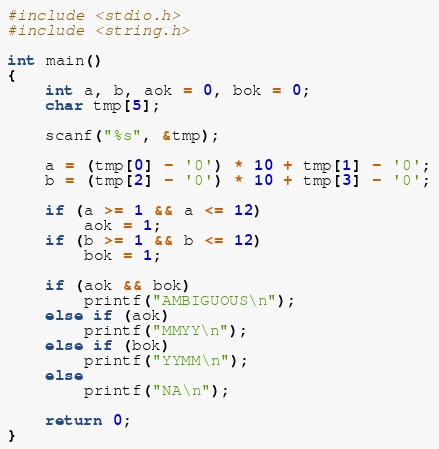Convert code to text. <code><loc_0><loc_0><loc_500><loc_500><_C_>#include <stdio.h>
#include <string.h>

int main()
{
	int a, b, aok = 0, bok = 0;
	char tmp[5];

	scanf("%s", &tmp);
	
	a = (tmp[0] - '0') * 10 + tmp[1] - '0';
	b = (tmp[2] - '0') * 10 + tmp[3] - '0';

	if (a >= 1 && a <= 12)
		aok = 1;
	if (b >= 1 && b <= 12)
		bok = 1;

	if (aok && bok)
		printf("AMBIGUOUS\n");
	else if (aok)
		printf("MMYY\n");
	else if (bok)
		printf("YYMM\n");
	else
		printf("NA\n");

	return 0;
}</code> 